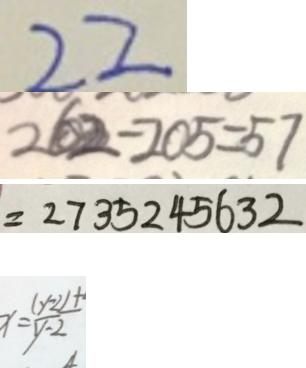Convert formula to latex. <formula><loc_0><loc_0><loc_500><loc_500>2 2 
 2 6 2 - 2 0 5 = 5 7 
 = 2 7 3 5 2 4 5 6 3 2 
 x = \frac { ( y - 2 ) + } { y - 2 }</formula> 